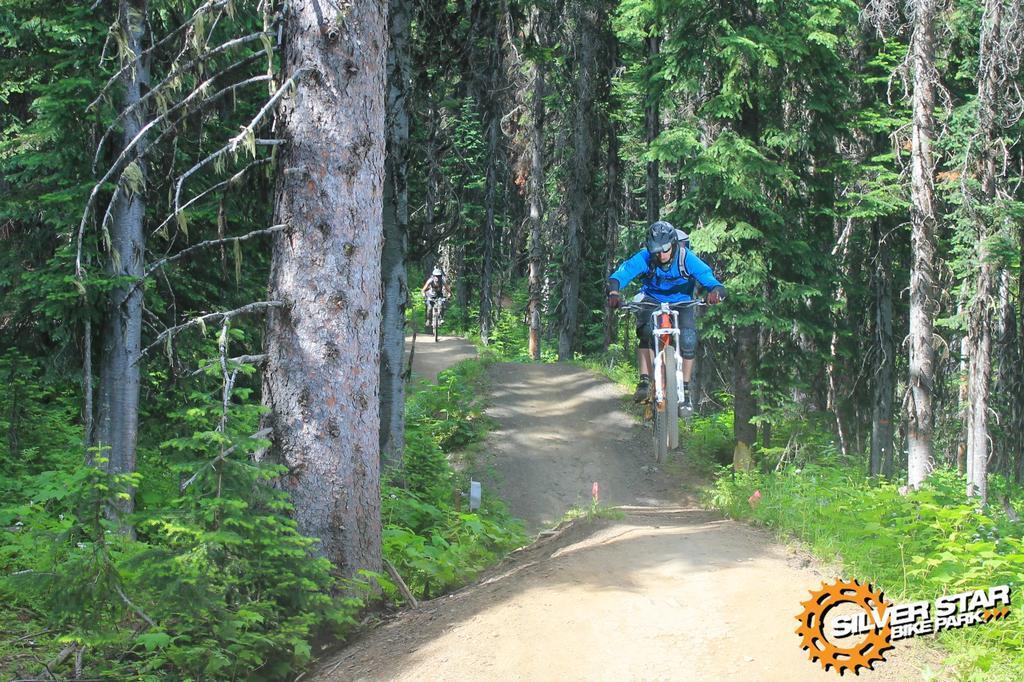Can you describe this image briefly? In this image I can see two people are sitting on their bicycles. I can see both of them are wearing helmets. I can also see a path, grass, shadow, number of trees and here I can see watermark. 